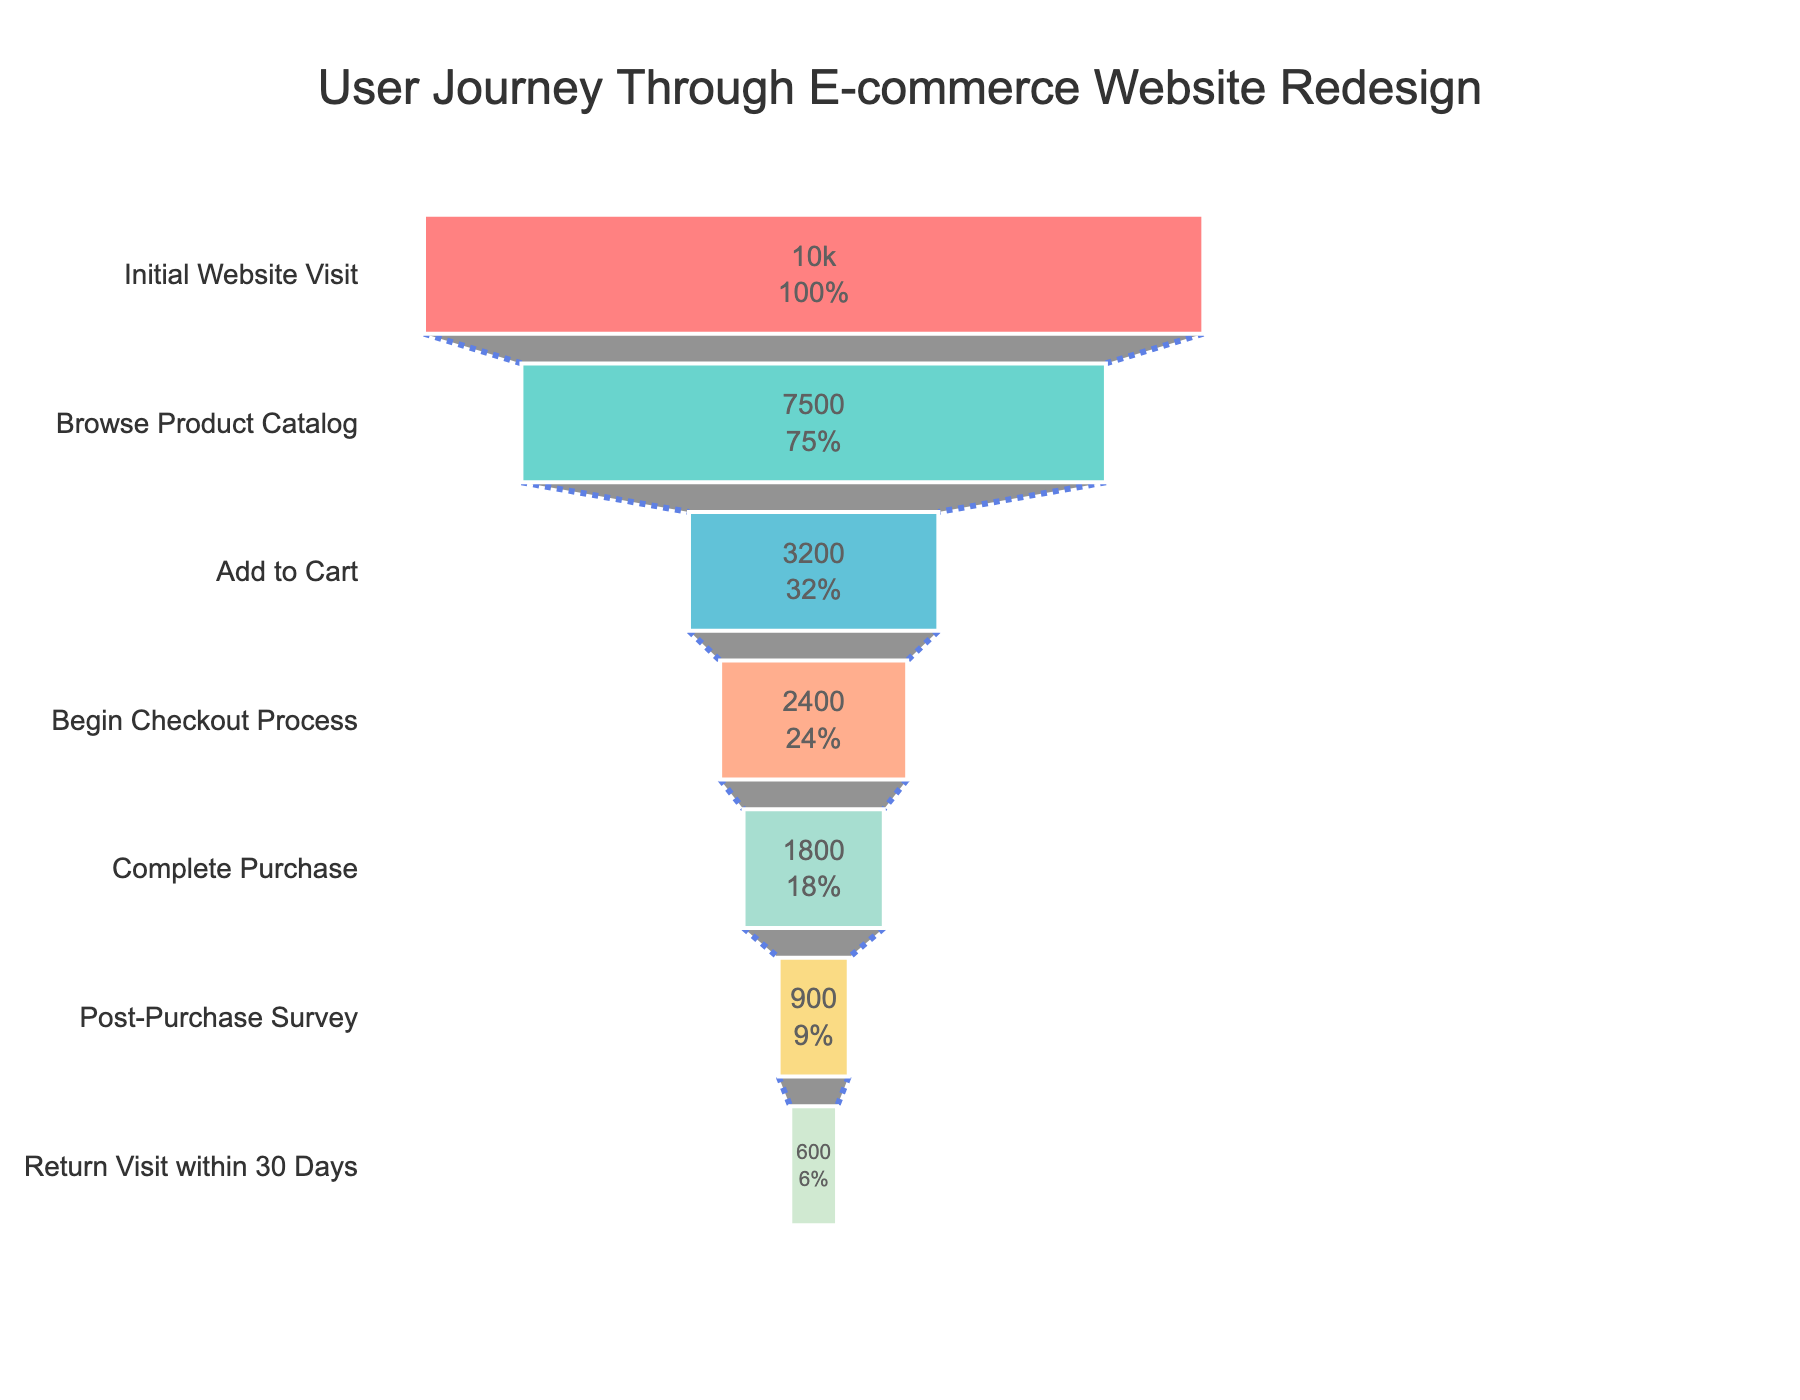what is the title of the chart? The title is typically displayed at the top of the chart. In this case, it is "User Journey Through E-commerce Website Redesign".
Answer: User Journey Through E-commerce Website Redesign How many data points are there in the funnel chart? The data points are the distinct stages of the user journey displayed on the chart. Counting them, we see stages like "Initial Website Visit", "Browse Product Catalog", etc.
Answer: 7 What percentage of users completed the purchase after beginning the checkout process? First, we find the stages concerned: "Begin Checkout Process" with 2400 users and "Complete Purchase" with 1800 users. The percentage is (1800 / 2400) * 100.
Answer: 75% What stage has the highest user drop-off and how many users dropped off at that stage? To find the drop-off, we look at the user difference between consecutive stages. The largest drop-off is between "Browse Product Catalog" (7500 users) and "Add to Cart" (3200 users); the drop-off is 7500 - 3200.
Answer: Browse Product Catalog, 4300 users Which stage has the fewest users and how many? Looking at the stages, "Return Visit within 30 Days" has the smallest number on the funnel with 600 users.
Answer: Return Visit within 30 Days, 600 users Compare the number of users who added items to the cart with those who visited the website initially. What is the difference? Users who visited the website initially are 10000, and those who added items to the cart are 3200. The difference is 10000 - 3200.
Answer: 6800 users What percentage of users who initially visited the website ended up returning within 30 days? First, note the initial visitors (10000 users) and return visitors within 30 days (600 users). The percentage is (600 / 10000) * 100.
Answer: 6% By what percentage did the number of users drop from completing the purchase to the post-purchase survey? The number of users who completed the purchase is 1800, while 900 users filled the post-purchase survey. The drop percentage is ((1800 - 900) / 1800) * 100.
Answer: 50% At which stage do the users drop below 50% of their initial number, and what is this percentage? Initial users are 10000; half of them is 10000 / 2 = 5000. The "Add to Cart" stage has 3200 users, which is below 50%. The percentage is (3200 / 10000) * 100.
Answer: Add to Cart, 32% How many colors are used to differentiate the stages in the funnel? The chart uses different colors to differentiate each stage visually. Count the number of unique colors used.
Answer: 7 